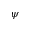<formula> <loc_0><loc_0><loc_500><loc_500>\psi</formula> 